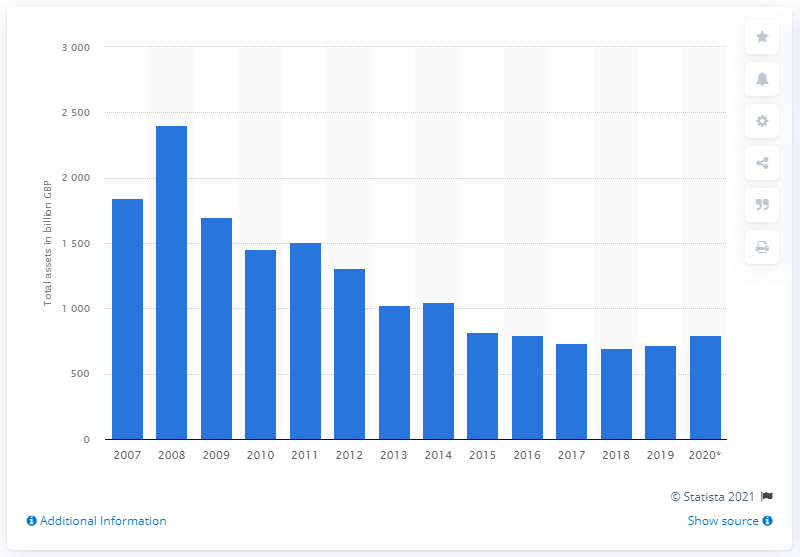Outline some significant characteristics in this image. The total assets of the NatWest group in 2007 were 2,401.7. In 2020, the total assets of the NatWest group were 799.49... 